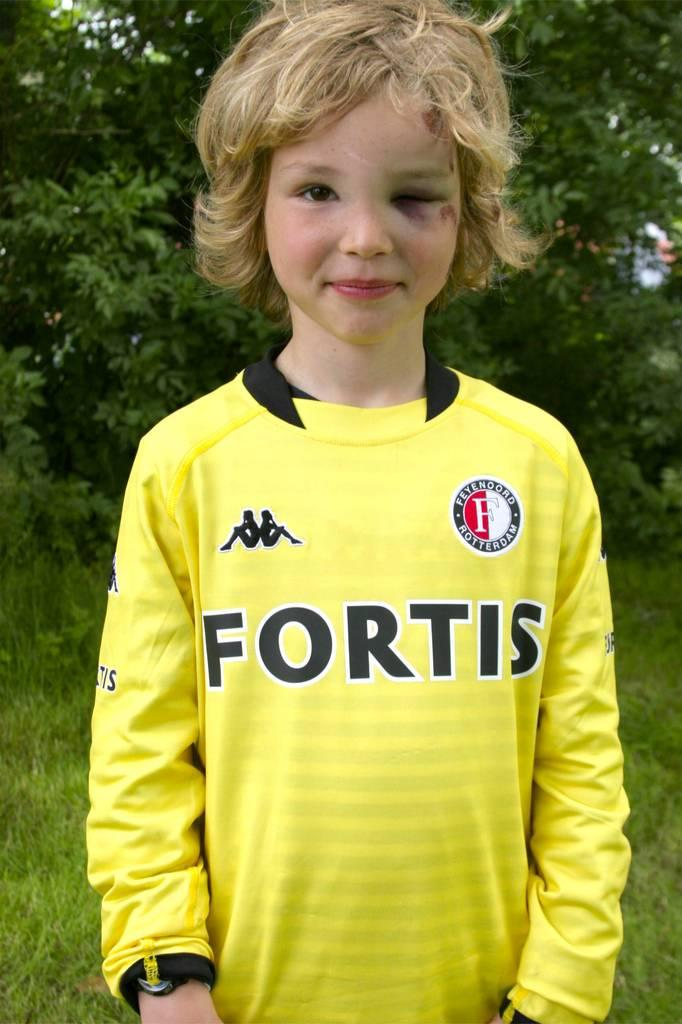<image>
Offer a succinct explanation of the picture presented. A child with a black eye stands wearing a yellow Fortis soccer jersey and smiles. 